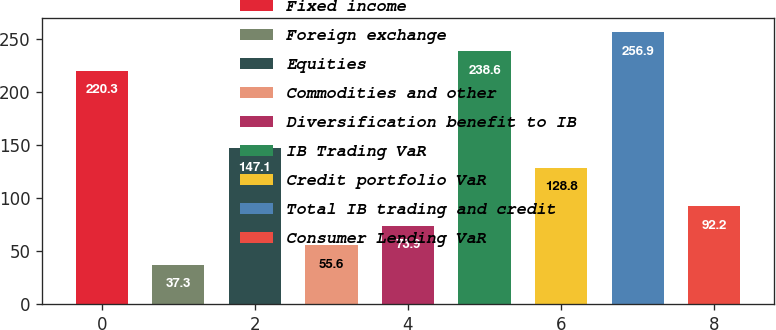Convert chart to OTSL. <chart><loc_0><loc_0><loc_500><loc_500><bar_chart><fcel>Fixed income<fcel>Foreign exchange<fcel>Equities<fcel>Commodities and other<fcel>Diversification benefit to IB<fcel>IB Trading VaR<fcel>Credit portfolio VaR<fcel>Total IB trading and credit<fcel>Consumer Lending VaR<nl><fcel>220.3<fcel>37.3<fcel>147.1<fcel>55.6<fcel>73.9<fcel>238.6<fcel>128.8<fcel>256.9<fcel>92.2<nl></chart> 